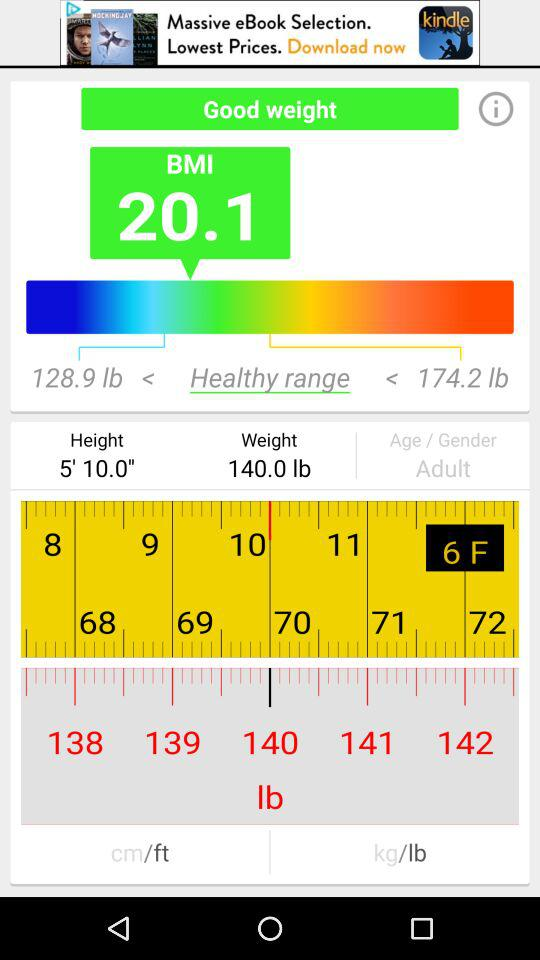What is the minimum height range?
When the provided information is insufficient, respond with <no answer>. <no answer> 